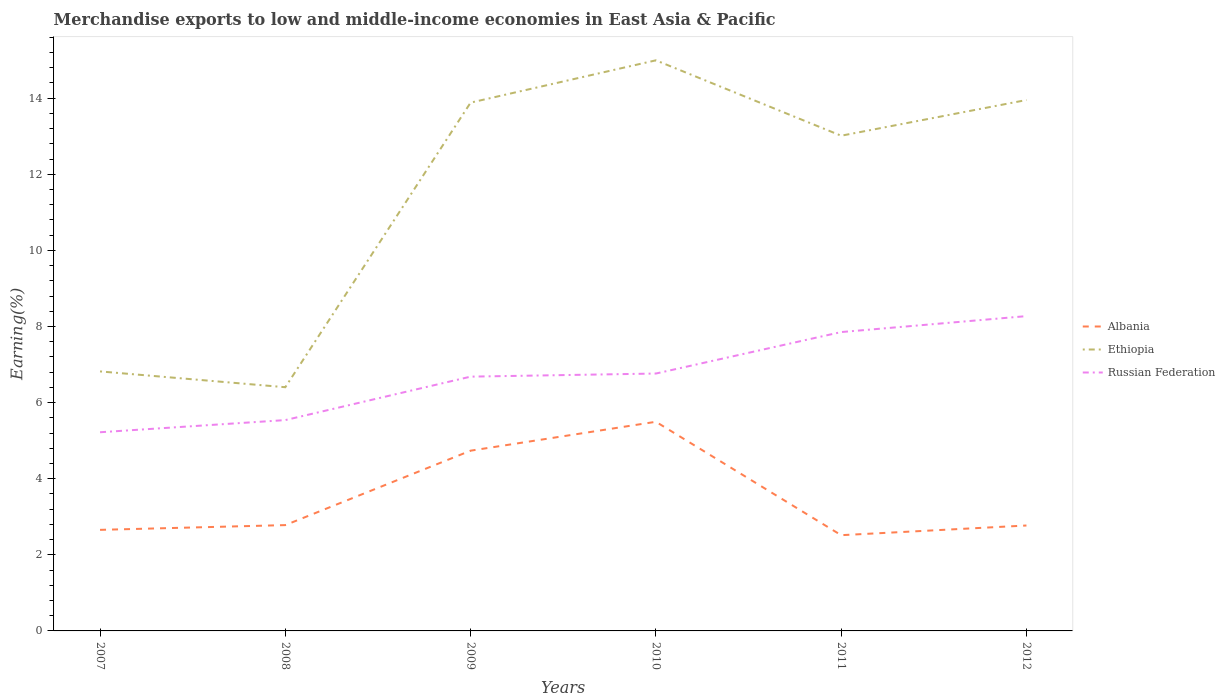How many different coloured lines are there?
Keep it short and to the point. 3. Across all years, what is the maximum percentage of amount earned from merchandise exports in Ethiopia?
Your answer should be compact. 6.4. What is the total percentage of amount earned from merchandise exports in Russian Federation in the graph?
Ensure brevity in your answer.  -1.51. What is the difference between the highest and the second highest percentage of amount earned from merchandise exports in Russian Federation?
Keep it short and to the point. 3.05. What is the difference between the highest and the lowest percentage of amount earned from merchandise exports in Russian Federation?
Offer a terse response. 3. How many years are there in the graph?
Ensure brevity in your answer.  6. What is the difference between two consecutive major ticks on the Y-axis?
Your answer should be compact. 2. How are the legend labels stacked?
Ensure brevity in your answer.  Vertical. What is the title of the graph?
Offer a very short reply. Merchandise exports to low and middle-income economies in East Asia & Pacific. Does "Haiti" appear as one of the legend labels in the graph?
Give a very brief answer. No. What is the label or title of the Y-axis?
Give a very brief answer. Earning(%). What is the Earning(%) of Albania in 2007?
Provide a succinct answer. 2.66. What is the Earning(%) of Ethiopia in 2007?
Provide a short and direct response. 6.82. What is the Earning(%) in Russian Federation in 2007?
Provide a short and direct response. 5.22. What is the Earning(%) in Albania in 2008?
Offer a terse response. 2.78. What is the Earning(%) of Ethiopia in 2008?
Keep it short and to the point. 6.4. What is the Earning(%) of Russian Federation in 2008?
Keep it short and to the point. 5.54. What is the Earning(%) in Albania in 2009?
Ensure brevity in your answer.  4.74. What is the Earning(%) of Ethiopia in 2009?
Your response must be concise. 13.88. What is the Earning(%) of Russian Federation in 2009?
Offer a very short reply. 6.68. What is the Earning(%) in Albania in 2010?
Offer a very short reply. 5.5. What is the Earning(%) of Ethiopia in 2010?
Offer a terse response. 14.99. What is the Earning(%) of Russian Federation in 2010?
Your answer should be compact. 6.76. What is the Earning(%) of Albania in 2011?
Offer a very short reply. 2.52. What is the Earning(%) in Ethiopia in 2011?
Offer a terse response. 13.01. What is the Earning(%) in Russian Federation in 2011?
Offer a terse response. 7.85. What is the Earning(%) in Albania in 2012?
Keep it short and to the point. 2.77. What is the Earning(%) of Ethiopia in 2012?
Offer a very short reply. 13.95. What is the Earning(%) in Russian Federation in 2012?
Ensure brevity in your answer.  8.27. Across all years, what is the maximum Earning(%) in Albania?
Keep it short and to the point. 5.5. Across all years, what is the maximum Earning(%) in Ethiopia?
Provide a succinct answer. 14.99. Across all years, what is the maximum Earning(%) in Russian Federation?
Provide a succinct answer. 8.27. Across all years, what is the minimum Earning(%) in Albania?
Your response must be concise. 2.52. Across all years, what is the minimum Earning(%) in Ethiopia?
Provide a short and direct response. 6.4. Across all years, what is the minimum Earning(%) of Russian Federation?
Keep it short and to the point. 5.22. What is the total Earning(%) in Albania in the graph?
Ensure brevity in your answer.  20.95. What is the total Earning(%) of Ethiopia in the graph?
Your response must be concise. 69.06. What is the total Earning(%) in Russian Federation in the graph?
Ensure brevity in your answer.  40.33. What is the difference between the Earning(%) in Albania in 2007 and that in 2008?
Offer a terse response. -0.12. What is the difference between the Earning(%) in Ethiopia in 2007 and that in 2008?
Provide a short and direct response. 0.42. What is the difference between the Earning(%) of Russian Federation in 2007 and that in 2008?
Keep it short and to the point. -0.32. What is the difference between the Earning(%) of Albania in 2007 and that in 2009?
Provide a succinct answer. -2.08. What is the difference between the Earning(%) of Ethiopia in 2007 and that in 2009?
Your answer should be compact. -7.06. What is the difference between the Earning(%) of Russian Federation in 2007 and that in 2009?
Provide a short and direct response. -1.46. What is the difference between the Earning(%) in Albania in 2007 and that in 2010?
Keep it short and to the point. -2.84. What is the difference between the Earning(%) of Ethiopia in 2007 and that in 2010?
Give a very brief answer. -8.17. What is the difference between the Earning(%) in Russian Federation in 2007 and that in 2010?
Offer a very short reply. -1.54. What is the difference between the Earning(%) in Albania in 2007 and that in 2011?
Offer a very short reply. 0.14. What is the difference between the Earning(%) in Ethiopia in 2007 and that in 2011?
Provide a succinct answer. -6.19. What is the difference between the Earning(%) of Russian Federation in 2007 and that in 2011?
Your response must be concise. -2.63. What is the difference between the Earning(%) in Albania in 2007 and that in 2012?
Provide a short and direct response. -0.11. What is the difference between the Earning(%) in Ethiopia in 2007 and that in 2012?
Your answer should be very brief. -7.13. What is the difference between the Earning(%) in Russian Federation in 2007 and that in 2012?
Your answer should be compact. -3.05. What is the difference between the Earning(%) of Albania in 2008 and that in 2009?
Offer a terse response. -1.96. What is the difference between the Earning(%) in Ethiopia in 2008 and that in 2009?
Offer a very short reply. -7.48. What is the difference between the Earning(%) in Russian Federation in 2008 and that in 2009?
Your answer should be compact. -1.14. What is the difference between the Earning(%) in Albania in 2008 and that in 2010?
Ensure brevity in your answer.  -2.72. What is the difference between the Earning(%) in Ethiopia in 2008 and that in 2010?
Provide a succinct answer. -8.59. What is the difference between the Earning(%) in Russian Federation in 2008 and that in 2010?
Give a very brief answer. -1.22. What is the difference between the Earning(%) of Albania in 2008 and that in 2011?
Offer a terse response. 0.26. What is the difference between the Earning(%) of Ethiopia in 2008 and that in 2011?
Offer a very short reply. -6.61. What is the difference between the Earning(%) in Russian Federation in 2008 and that in 2011?
Your response must be concise. -2.31. What is the difference between the Earning(%) in Albania in 2008 and that in 2012?
Offer a very short reply. 0.01. What is the difference between the Earning(%) in Ethiopia in 2008 and that in 2012?
Offer a terse response. -7.55. What is the difference between the Earning(%) in Russian Federation in 2008 and that in 2012?
Give a very brief answer. -2.73. What is the difference between the Earning(%) in Albania in 2009 and that in 2010?
Make the answer very short. -0.76. What is the difference between the Earning(%) in Ethiopia in 2009 and that in 2010?
Provide a succinct answer. -1.11. What is the difference between the Earning(%) of Russian Federation in 2009 and that in 2010?
Give a very brief answer. -0.08. What is the difference between the Earning(%) of Albania in 2009 and that in 2011?
Your answer should be compact. 2.22. What is the difference between the Earning(%) of Ethiopia in 2009 and that in 2011?
Your response must be concise. 0.87. What is the difference between the Earning(%) in Russian Federation in 2009 and that in 2011?
Make the answer very short. -1.17. What is the difference between the Earning(%) in Albania in 2009 and that in 2012?
Your response must be concise. 1.97. What is the difference between the Earning(%) in Ethiopia in 2009 and that in 2012?
Ensure brevity in your answer.  -0.07. What is the difference between the Earning(%) of Russian Federation in 2009 and that in 2012?
Give a very brief answer. -1.59. What is the difference between the Earning(%) of Albania in 2010 and that in 2011?
Your answer should be compact. 2.98. What is the difference between the Earning(%) in Ethiopia in 2010 and that in 2011?
Your answer should be compact. 1.98. What is the difference between the Earning(%) in Russian Federation in 2010 and that in 2011?
Your response must be concise. -1.09. What is the difference between the Earning(%) of Albania in 2010 and that in 2012?
Provide a succinct answer. 2.73. What is the difference between the Earning(%) of Ethiopia in 2010 and that in 2012?
Offer a very short reply. 1.04. What is the difference between the Earning(%) of Russian Federation in 2010 and that in 2012?
Ensure brevity in your answer.  -1.51. What is the difference between the Earning(%) of Albania in 2011 and that in 2012?
Offer a very short reply. -0.25. What is the difference between the Earning(%) in Ethiopia in 2011 and that in 2012?
Your answer should be very brief. -0.94. What is the difference between the Earning(%) in Russian Federation in 2011 and that in 2012?
Make the answer very short. -0.42. What is the difference between the Earning(%) of Albania in 2007 and the Earning(%) of Ethiopia in 2008?
Provide a short and direct response. -3.75. What is the difference between the Earning(%) in Albania in 2007 and the Earning(%) in Russian Federation in 2008?
Give a very brief answer. -2.88. What is the difference between the Earning(%) in Ethiopia in 2007 and the Earning(%) in Russian Federation in 2008?
Give a very brief answer. 1.28. What is the difference between the Earning(%) in Albania in 2007 and the Earning(%) in Ethiopia in 2009?
Provide a succinct answer. -11.23. What is the difference between the Earning(%) of Albania in 2007 and the Earning(%) of Russian Federation in 2009?
Your answer should be very brief. -4.03. What is the difference between the Earning(%) in Ethiopia in 2007 and the Earning(%) in Russian Federation in 2009?
Your response must be concise. 0.14. What is the difference between the Earning(%) of Albania in 2007 and the Earning(%) of Ethiopia in 2010?
Provide a succinct answer. -12.34. What is the difference between the Earning(%) in Albania in 2007 and the Earning(%) in Russian Federation in 2010?
Your answer should be compact. -4.11. What is the difference between the Earning(%) in Ethiopia in 2007 and the Earning(%) in Russian Federation in 2010?
Provide a short and direct response. 0.06. What is the difference between the Earning(%) of Albania in 2007 and the Earning(%) of Ethiopia in 2011?
Your answer should be compact. -10.36. What is the difference between the Earning(%) of Albania in 2007 and the Earning(%) of Russian Federation in 2011?
Provide a succinct answer. -5.2. What is the difference between the Earning(%) in Ethiopia in 2007 and the Earning(%) in Russian Federation in 2011?
Offer a terse response. -1.03. What is the difference between the Earning(%) of Albania in 2007 and the Earning(%) of Ethiopia in 2012?
Give a very brief answer. -11.3. What is the difference between the Earning(%) of Albania in 2007 and the Earning(%) of Russian Federation in 2012?
Make the answer very short. -5.62. What is the difference between the Earning(%) in Ethiopia in 2007 and the Earning(%) in Russian Federation in 2012?
Your response must be concise. -1.45. What is the difference between the Earning(%) in Albania in 2008 and the Earning(%) in Ethiopia in 2009?
Provide a short and direct response. -11.1. What is the difference between the Earning(%) of Albania in 2008 and the Earning(%) of Russian Federation in 2009?
Your response must be concise. -3.9. What is the difference between the Earning(%) of Ethiopia in 2008 and the Earning(%) of Russian Federation in 2009?
Give a very brief answer. -0.28. What is the difference between the Earning(%) of Albania in 2008 and the Earning(%) of Ethiopia in 2010?
Give a very brief answer. -12.21. What is the difference between the Earning(%) of Albania in 2008 and the Earning(%) of Russian Federation in 2010?
Your answer should be very brief. -3.98. What is the difference between the Earning(%) of Ethiopia in 2008 and the Earning(%) of Russian Federation in 2010?
Your answer should be compact. -0.36. What is the difference between the Earning(%) in Albania in 2008 and the Earning(%) in Ethiopia in 2011?
Offer a very short reply. -10.23. What is the difference between the Earning(%) in Albania in 2008 and the Earning(%) in Russian Federation in 2011?
Provide a succinct answer. -5.07. What is the difference between the Earning(%) of Ethiopia in 2008 and the Earning(%) of Russian Federation in 2011?
Give a very brief answer. -1.45. What is the difference between the Earning(%) in Albania in 2008 and the Earning(%) in Ethiopia in 2012?
Ensure brevity in your answer.  -11.17. What is the difference between the Earning(%) of Albania in 2008 and the Earning(%) of Russian Federation in 2012?
Offer a very short reply. -5.49. What is the difference between the Earning(%) of Ethiopia in 2008 and the Earning(%) of Russian Federation in 2012?
Your response must be concise. -1.87. What is the difference between the Earning(%) in Albania in 2009 and the Earning(%) in Ethiopia in 2010?
Offer a very short reply. -10.26. What is the difference between the Earning(%) of Albania in 2009 and the Earning(%) of Russian Federation in 2010?
Offer a terse response. -2.03. What is the difference between the Earning(%) in Ethiopia in 2009 and the Earning(%) in Russian Federation in 2010?
Offer a very short reply. 7.12. What is the difference between the Earning(%) of Albania in 2009 and the Earning(%) of Ethiopia in 2011?
Make the answer very short. -8.28. What is the difference between the Earning(%) of Albania in 2009 and the Earning(%) of Russian Federation in 2011?
Keep it short and to the point. -3.12. What is the difference between the Earning(%) in Ethiopia in 2009 and the Earning(%) in Russian Federation in 2011?
Provide a short and direct response. 6.03. What is the difference between the Earning(%) of Albania in 2009 and the Earning(%) of Ethiopia in 2012?
Provide a short and direct response. -9.21. What is the difference between the Earning(%) of Albania in 2009 and the Earning(%) of Russian Federation in 2012?
Provide a short and direct response. -3.54. What is the difference between the Earning(%) in Ethiopia in 2009 and the Earning(%) in Russian Federation in 2012?
Offer a terse response. 5.61. What is the difference between the Earning(%) in Albania in 2010 and the Earning(%) in Ethiopia in 2011?
Your response must be concise. -7.52. What is the difference between the Earning(%) in Albania in 2010 and the Earning(%) in Russian Federation in 2011?
Make the answer very short. -2.36. What is the difference between the Earning(%) in Ethiopia in 2010 and the Earning(%) in Russian Federation in 2011?
Provide a short and direct response. 7.14. What is the difference between the Earning(%) in Albania in 2010 and the Earning(%) in Ethiopia in 2012?
Offer a very short reply. -8.46. What is the difference between the Earning(%) of Albania in 2010 and the Earning(%) of Russian Federation in 2012?
Offer a very short reply. -2.78. What is the difference between the Earning(%) in Ethiopia in 2010 and the Earning(%) in Russian Federation in 2012?
Make the answer very short. 6.72. What is the difference between the Earning(%) in Albania in 2011 and the Earning(%) in Ethiopia in 2012?
Offer a terse response. -11.44. What is the difference between the Earning(%) of Albania in 2011 and the Earning(%) of Russian Federation in 2012?
Ensure brevity in your answer.  -5.76. What is the difference between the Earning(%) in Ethiopia in 2011 and the Earning(%) in Russian Federation in 2012?
Keep it short and to the point. 4.74. What is the average Earning(%) in Albania per year?
Keep it short and to the point. 3.49. What is the average Earning(%) in Ethiopia per year?
Provide a short and direct response. 11.51. What is the average Earning(%) of Russian Federation per year?
Offer a terse response. 6.72. In the year 2007, what is the difference between the Earning(%) of Albania and Earning(%) of Ethiopia?
Offer a terse response. -4.16. In the year 2007, what is the difference between the Earning(%) of Albania and Earning(%) of Russian Federation?
Make the answer very short. -2.56. In the year 2007, what is the difference between the Earning(%) of Ethiopia and Earning(%) of Russian Federation?
Offer a terse response. 1.6. In the year 2008, what is the difference between the Earning(%) in Albania and Earning(%) in Ethiopia?
Your response must be concise. -3.62. In the year 2008, what is the difference between the Earning(%) in Albania and Earning(%) in Russian Federation?
Your answer should be very brief. -2.76. In the year 2008, what is the difference between the Earning(%) of Ethiopia and Earning(%) of Russian Federation?
Provide a short and direct response. 0.86. In the year 2009, what is the difference between the Earning(%) of Albania and Earning(%) of Ethiopia?
Your response must be concise. -9.15. In the year 2009, what is the difference between the Earning(%) in Albania and Earning(%) in Russian Federation?
Your answer should be very brief. -1.95. In the year 2009, what is the difference between the Earning(%) in Ethiopia and Earning(%) in Russian Federation?
Provide a succinct answer. 7.2. In the year 2010, what is the difference between the Earning(%) in Albania and Earning(%) in Ethiopia?
Ensure brevity in your answer.  -9.5. In the year 2010, what is the difference between the Earning(%) in Albania and Earning(%) in Russian Federation?
Ensure brevity in your answer.  -1.27. In the year 2010, what is the difference between the Earning(%) of Ethiopia and Earning(%) of Russian Federation?
Your answer should be compact. 8.23. In the year 2011, what is the difference between the Earning(%) in Albania and Earning(%) in Ethiopia?
Provide a succinct answer. -10.5. In the year 2011, what is the difference between the Earning(%) of Albania and Earning(%) of Russian Federation?
Give a very brief answer. -5.34. In the year 2011, what is the difference between the Earning(%) of Ethiopia and Earning(%) of Russian Federation?
Your answer should be very brief. 5.16. In the year 2012, what is the difference between the Earning(%) of Albania and Earning(%) of Ethiopia?
Keep it short and to the point. -11.18. In the year 2012, what is the difference between the Earning(%) in Albania and Earning(%) in Russian Federation?
Give a very brief answer. -5.5. In the year 2012, what is the difference between the Earning(%) of Ethiopia and Earning(%) of Russian Federation?
Keep it short and to the point. 5.68. What is the ratio of the Earning(%) in Albania in 2007 to that in 2008?
Offer a terse response. 0.96. What is the ratio of the Earning(%) of Ethiopia in 2007 to that in 2008?
Your response must be concise. 1.06. What is the ratio of the Earning(%) in Russian Federation in 2007 to that in 2008?
Ensure brevity in your answer.  0.94. What is the ratio of the Earning(%) of Albania in 2007 to that in 2009?
Your response must be concise. 0.56. What is the ratio of the Earning(%) of Ethiopia in 2007 to that in 2009?
Ensure brevity in your answer.  0.49. What is the ratio of the Earning(%) in Russian Federation in 2007 to that in 2009?
Give a very brief answer. 0.78. What is the ratio of the Earning(%) of Albania in 2007 to that in 2010?
Your answer should be compact. 0.48. What is the ratio of the Earning(%) in Ethiopia in 2007 to that in 2010?
Your response must be concise. 0.45. What is the ratio of the Earning(%) in Russian Federation in 2007 to that in 2010?
Keep it short and to the point. 0.77. What is the ratio of the Earning(%) in Albania in 2007 to that in 2011?
Provide a short and direct response. 1.06. What is the ratio of the Earning(%) of Ethiopia in 2007 to that in 2011?
Your answer should be compact. 0.52. What is the ratio of the Earning(%) of Russian Federation in 2007 to that in 2011?
Keep it short and to the point. 0.66. What is the ratio of the Earning(%) in Albania in 2007 to that in 2012?
Offer a terse response. 0.96. What is the ratio of the Earning(%) in Ethiopia in 2007 to that in 2012?
Give a very brief answer. 0.49. What is the ratio of the Earning(%) in Russian Federation in 2007 to that in 2012?
Make the answer very short. 0.63. What is the ratio of the Earning(%) in Albania in 2008 to that in 2009?
Provide a succinct answer. 0.59. What is the ratio of the Earning(%) in Ethiopia in 2008 to that in 2009?
Keep it short and to the point. 0.46. What is the ratio of the Earning(%) of Russian Federation in 2008 to that in 2009?
Offer a very short reply. 0.83. What is the ratio of the Earning(%) in Albania in 2008 to that in 2010?
Provide a short and direct response. 0.51. What is the ratio of the Earning(%) of Ethiopia in 2008 to that in 2010?
Keep it short and to the point. 0.43. What is the ratio of the Earning(%) of Russian Federation in 2008 to that in 2010?
Make the answer very short. 0.82. What is the ratio of the Earning(%) of Albania in 2008 to that in 2011?
Provide a succinct answer. 1.11. What is the ratio of the Earning(%) in Ethiopia in 2008 to that in 2011?
Ensure brevity in your answer.  0.49. What is the ratio of the Earning(%) in Russian Federation in 2008 to that in 2011?
Your answer should be compact. 0.71. What is the ratio of the Earning(%) in Ethiopia in 2008 to that in 2012?
Provide a short and direct response. 0.46. What is the ratio of the Earning(%) of Russian Federation in 2008 to that in 2012?
Keep it short and to the point. 0.67. What is the ratio of the Earning(%) in Albania in 2009 to that in 2010?
Offer a terse response. 0.86. What is the ratio of the Earning(%) in Ethiopia in 2009 to that in 2010?
Your answer should be compact. 0.93. What is the ratio of the Earning(%) in Albania in 2009 to that in 2011?
Your response must be concise. 1.88. What is the ratio of the Earning(%) in Ethiopia in 2009 to that in 2011?
Make the answer very short. 1.07. What is the ratio of the Earning(%) in Russian Federation in 2009 to that in 2011?
Provide a succinct answer. 0.85. What is the ratio of the Earning(%) of Albania in 2009 to that in 2012?
Keep it short and to the point. 1.71. What is the ratio of the Earning(%) of Ethiopia in 2009 to that in 2012?
Provide a short and direct response. 1. What is the ratio of the Earning(%) of Russian Federation in 2009 to that in 2012?
Keep it short and to the point. 0.81. What is the ratio of the Earning(%) of Albania in 2010 to that in 2011?
Provide a short and direct response. 2.18. What is the ratio of the Earning(%) of Ethiopia in 2010 to that in 2011?
Offer a very short reply. 1.15. What is the ratio of the Earning(%) of Russian Federation in 2010 to that in 2011?
Your answer should be very brief. 0.86. What is the ratio of the Earning(%) in Albania in 2010 to that in 2012?
Provide a short and direct response. 1.98. What is the ratio of the Earning(%) of Ethiopia in 2010 to that in 2012?
Keep it short and to the point. 1.07. What is the ratio of the Earning(%) in Russian Federation in 2010 to that in 2012?
Keep it short and to the point. 0.82. What is the ratio of the Earning(%) in Albania in 2011 to that in 2012?
Make the answer very short. 0.91. What is the ratio of the Earning(%) in Ethiopia in 2011 to that in 2012?
Give a very brief answer. 0.93. What is the ratio of the Earning(%) of Russian Federation in 2011 to that in 2012?
Ensure brevity in your answer.  0.95. What is the difference between the highest and the second highest Earning(%) of Albania?
Provide a succinct answer. 0.76. What is the difference between the highest and the second highest Earning(%) in Ethiopia?
Make the answer very short. 1.04. What is the difference between the highest and the second highest Earning(%) of Russian Federation?
Ensure brevity in your answer.  0.42. What is the difference between the highest and the lowest Earning(%) of Albania?
Offer a very short reply. 2.98. What is the difference between the highest and the lowest Earning(%) of Ethiopia?
Keep it short and to the point. 8.59. What is the difference between the highest and the lowest Earning(%) in Russian Federation?
Your answer should be very brief. 3.05. 